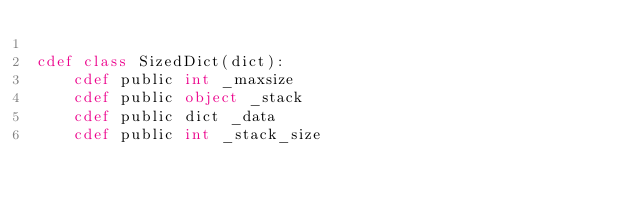Convert code to text. <code><loc_0><loc_0><loc_500><loc_500><_Cython_>
cdef class SizedDict(dict):
    cdef public int _maxsize
    cdef public object _stack
    cdef public dict _data
    cdef public int _stack_size
</code> 